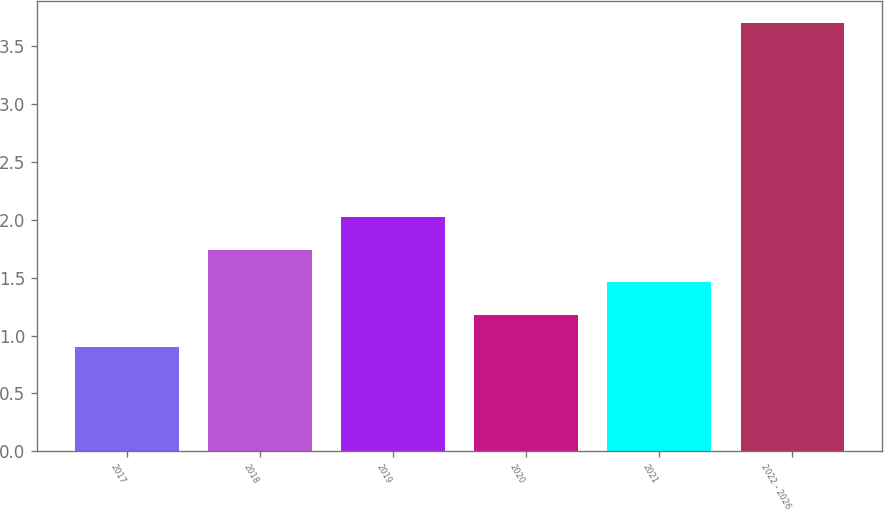<chart> <loc_0><loc_0><loc_500><loc_500><bar_chart><fcel>2017<fcel>2018<fcel>2019<fcel>2020<fcel>2021<fcel>2022 - 2026<nl><fcel>0.9<fcel>1.74<fcel>2.02<fcel>1.18<fcel>1.46<fcel>3.7<nl></chart> 